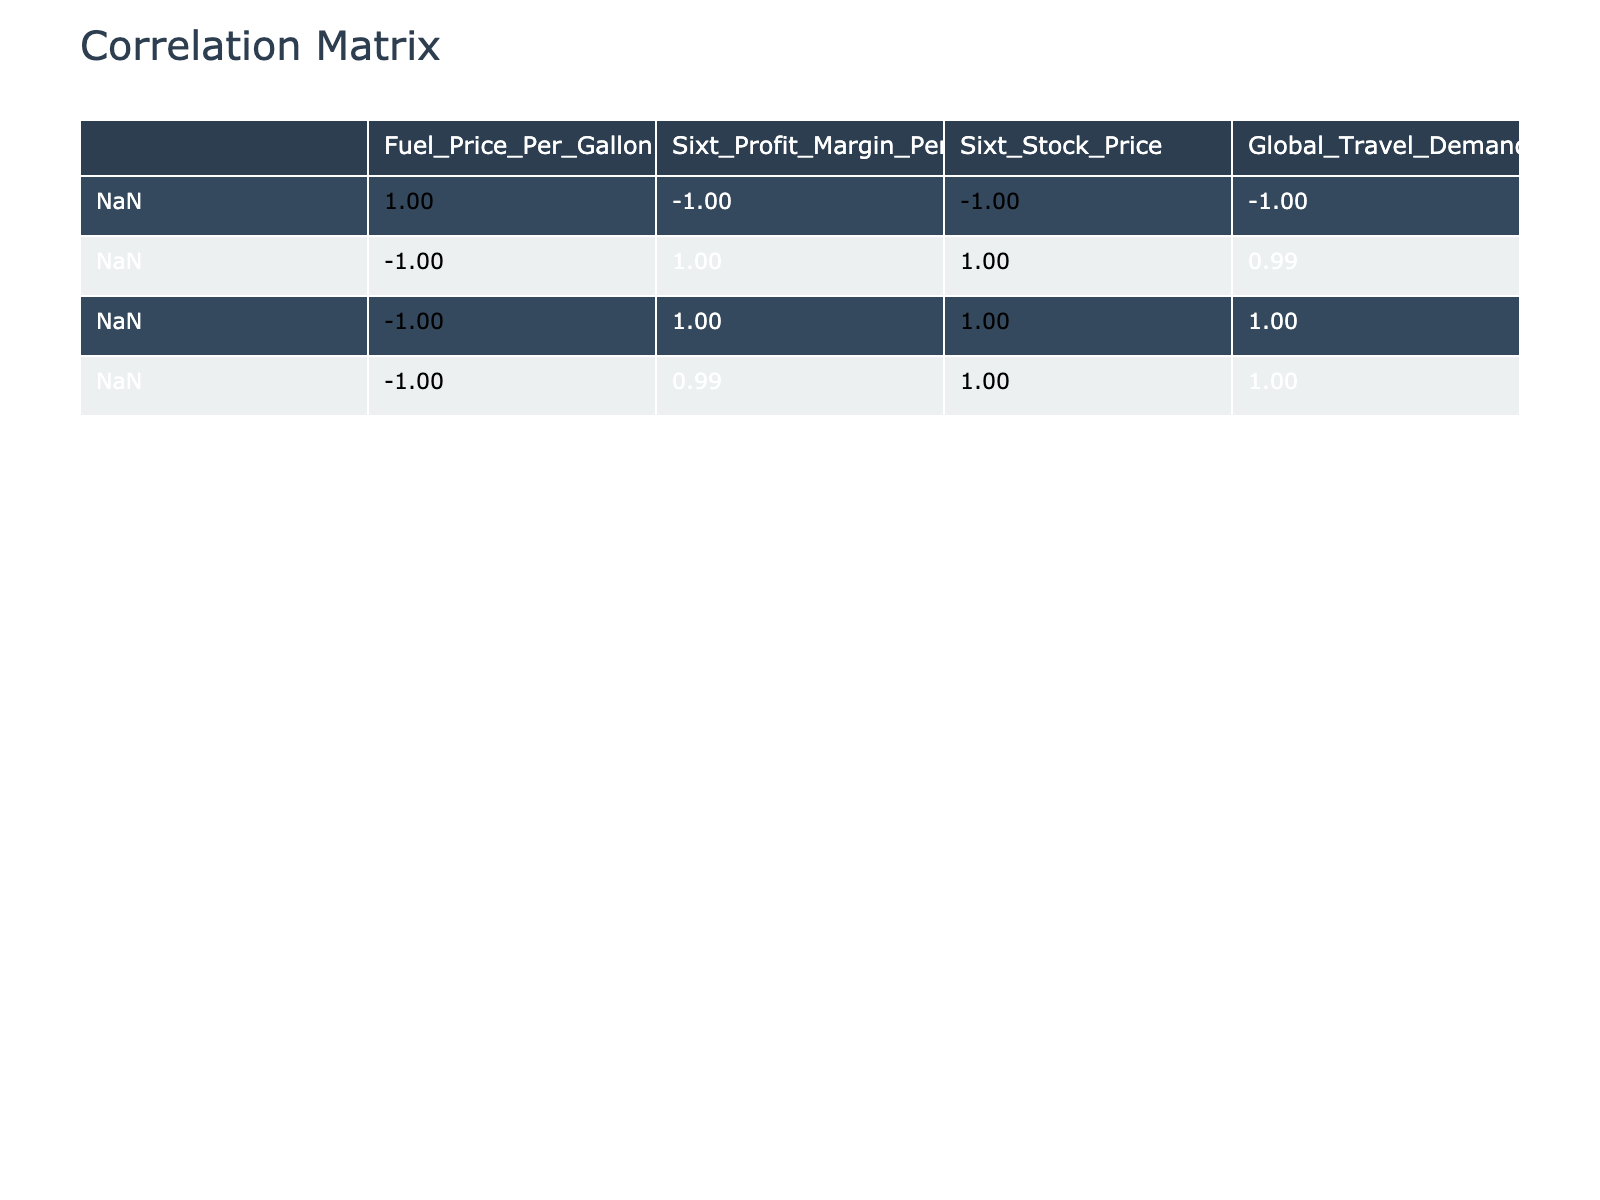What is the correlation between fuel prices and Sixt's profit margin? From the correlation table, we look at the cell that intersects the rows "Fuel_Price_Per_Gallon" and "Sixt_Profit_Margin_Percent". The value there is -0.97, indicating a strong negative correlation. This means that as fuel prices increase, Sixt's profit margin tends to decrease.
Answer: -0.97 What is the highest recorded fuel price in the table? To find this, we survey the "Fuel_Price_Per_Gallon" column and identify the largest value listed. The highest fuel price recorded is 4.90.
Answer: 4.90 Did Sixt's stock price decrease as fuel prices rose? We analyze the correlation between "Fuel_Price_Per_Gallon" and "Sixt_Stock_Price". The table shows a correlation of -0.94, suggesting that an increase in fuel prices is associated with a decrease in Sixt's stock price.
Answer: Yes What was the profit margin when the fuel price was at its highest? We refer to the row where "Fuel_Price_Per_Gallon" is 4.90 and read the corresponding "Sixt_Profit_Margin_Percent". The profit margin at this fuel price was 7.0 percent.
Answer: 7.0 percent What is the average profit margin over the given period? To calculate the average, we sum up all the profit margin percentages listed: (12.5 + 12.0 + 11.8 + 11.5 + 11.0 + 10.5 + 10.0 + 9.8 + 9.5 + 9.0 + 8.8 + 8.5 + 8.0 + 7.5 + 7.0) = 159.6. There are 15 data points, so the average is 159.6 / 15 = 10.64.
Answer: 10.64 How much did Sixt's stock price decline from January 2022 to March 2023? We compare the stock price on January 1, 2022, which is 28.00, and the stock price on March 1, 2023, which is 20.00. The decline is calculated as 28.00 - 20.00 = 8.00.
Answer: 8.00 